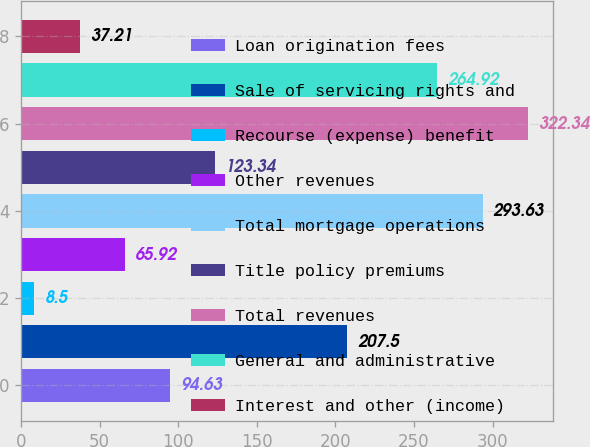Convert chart. <chart><loc_0><loc_0><loc_500><loc_500><bar_chart><fcel>Loan origination fees<fcel>Sale of servicing rights and<fcel>Recourse (expense) benefit<fcel>Other revenues<fcel>Total mortgage operations<fcel>Title policy premiums<fcel>Total revenues<fcel>General and administrative<fcel>Interest and other (income)<nl><fcel>94.63<fcel>207.5<fcel>8.5<fcel>65.92<fcel>293.63<fcel>123.34<fcel>322.34<fcel>264.92<fcel>37.21<nl></chart> 